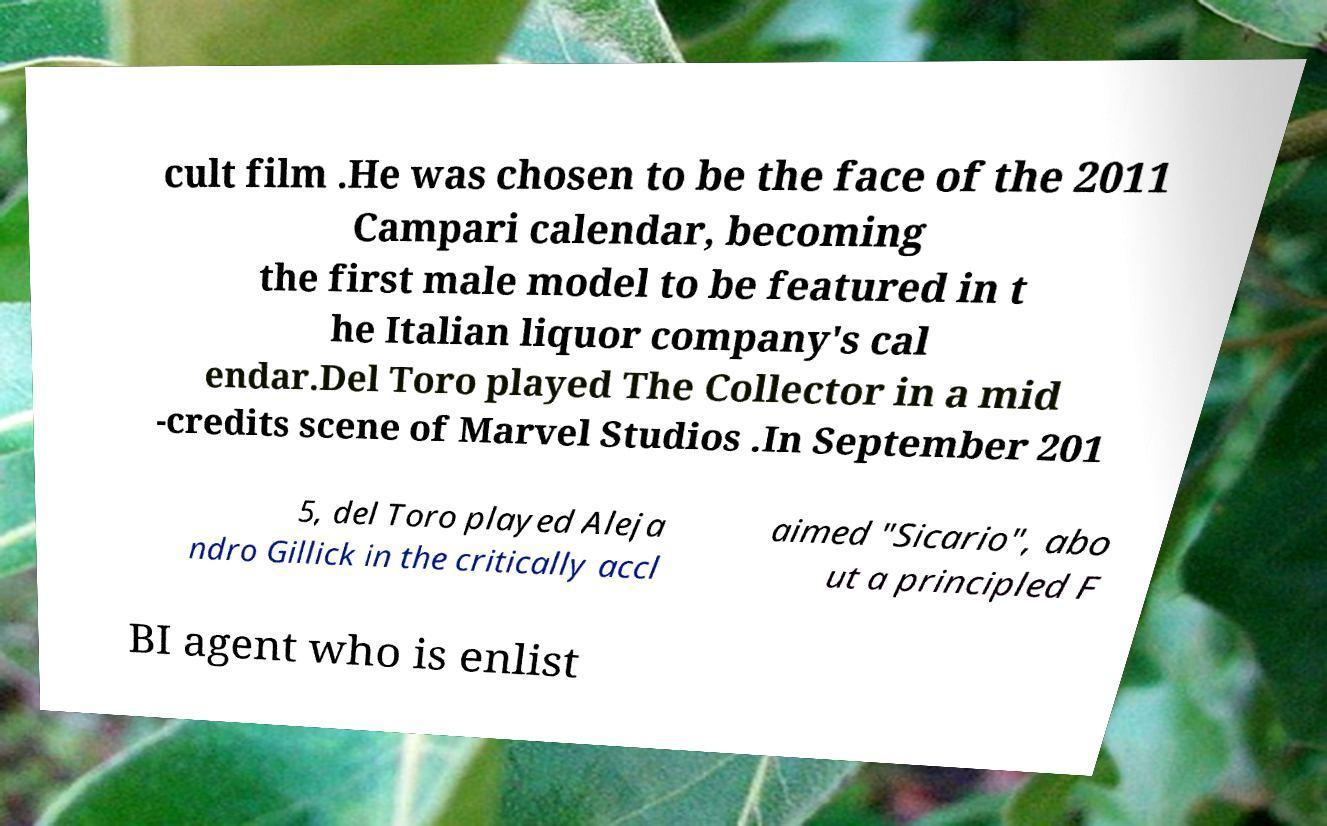Can you accurately transcribe the text from the provided image for me? cult film .He was chosen to be the face of the 2011 Campari calendar, becoming the first male model to be featured in t he Italian liquor company's cal endar.Del Toro played The Collector in a mid -credits scene of Marvel Studios .In September 201 5, del Toro played Aleja ndro Gillick in the critically accl aimed "Sicario", abo ut a principled F BI agent who is enlist 